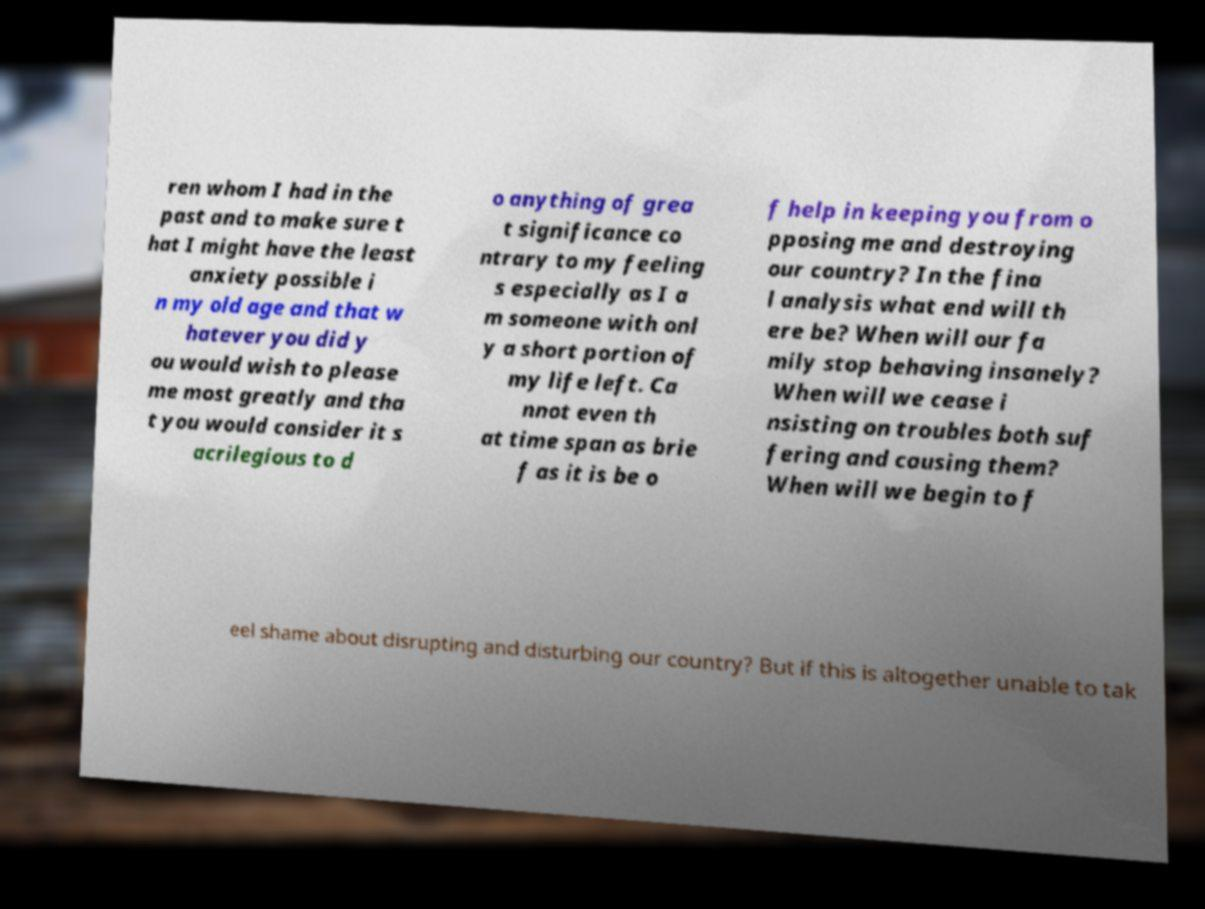There's text embedded in this image that I need extracted. Can you transcribe it verbatim? ren whom I had in the past and to make sure t hat I might have the least anxiety possible i n my old age and that w hatever you did y ou would wish to please me most greatly and tha t you would consider it s acrilegious to d o anything of grea t significance co ntrary to my feeling s especially as I a m someone with onl y a short portion of my life left. Ca nnot even th at time span as brie f as it is be o f help in keeping you from o pposing me and destroying our country? In the fina l analysis what end will th ere be? When will our fa mily stop behaving insanely? When will we cease i nsisting on troubles both suf fering and causing them? When will we begin to f eel shame about disrupting and disturbing our country? But if this is altogether unable to tak 